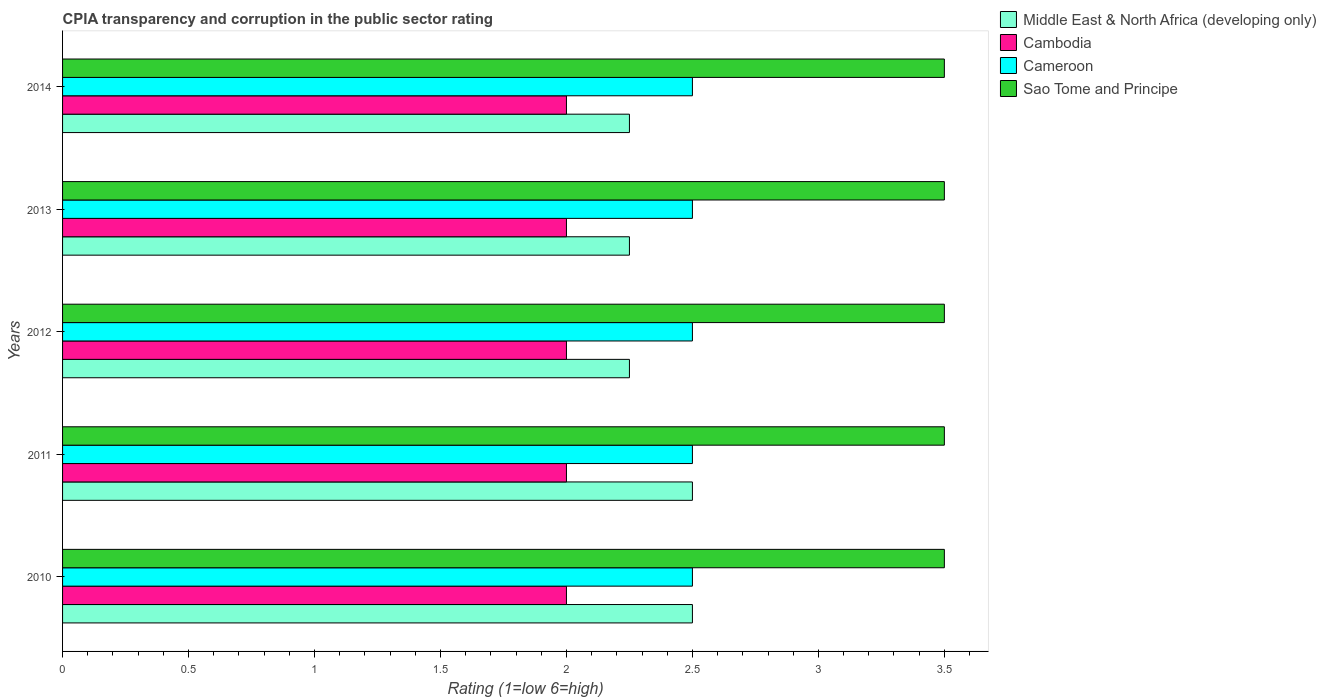How many groups of bars are there?
Provide a short and direct response. 5. How many bars are there on the 2nd tick from the bottom?
Keep it short and to the point. 4. What is the difference between the CPIA rating in Sao Tome and Principe in 2012 and that in 2013?
Offer a terse response. 0. What is the difference between the CPIA rating in Middle East & North Africa (developing only) in 2010 and the CPIA rating in Cameroon in 2013?
Offer a very short reply. 0. What is the average CPIA rating in Middle East & North Africa (developing only) per year?
Ensure brevity in your answer.  2.35. In the year 2014, what is the difference between the CPIA rating in Cambodia and CPIA rating in Middle East & North Africa (developing only)?
Offer a terse response. -0.25. In how many years, is the CPIA rating in Sao Tome and Principe greater than 1.7 ?
Offer a very short reply. 5. What is the ratio of the CPIA rating in Middle East & North Africa (developing only) in 2011 to that in 2012?
Give a very brief answer. 1.11. Is the CPIA rating in Middle East & North Africa (developing only) in 2010 less than that in 2012?
Offer a very short reply. No. Is the difference between the CPIA rating in Cambodia in 2012 and 2013 greater than the difference between the CPIA rating in Middle East & North Africa (developing only) in 2012 and 2013?
Keep it short and to the point. No. In how many years, is the CPIA rating in Cambodia greater than the average CPIA rating in Cambodia taken over all years?
Your response must be concise. 0. Is it the case that in every year, the sum of the CPIA rating in Middle East & North Africa (developing only) and CPIA rating in Cambodia is greater than the sum of CPIA rating in Sao Tome and Principe and CPIA rating in Cameroon?
Ensure brevity in your answer.  No. What does the 2nd bar from the top in 2014 represents?
Offer a very short reply. Cameroon. What does the 3rd bar from the bottom in 2014 represents?
Give a very brief answer. Cameroon. How many bars are there?
Give a very brief answer. 20. How many years are there in the graph?
Provide a short and direct response. 5. Are the values on the major ticks of X-axis written in scientific E-notation?
Offer a terse response. No. Does the graph contain any zero values?
Keep it short and to the point. No. Does the graph contain grids?
Offer a very short reply. No. How are the legend labels stacked?
Your answer should be very brief. Vertical. What is the title of the graph?
Your answer should be compact. CPIA transparency and corruption in the public sector rating. What is the Rating (1=low 6=high) in Middle East & North Africa (developing only) in 2010?
Offer a very short reply. 2.5. What is the Rating (1=low 6=high) in Cambodia in 2010?
Your answer should be compact. 2. What is the Rating (1=low 6=high) of Sao Tome and Principe in 2010?
Give a very brief answer. 3.5. What is the Rating (1=low 6=high) in Cameroon in 2011?
Offer a very short reply. 2.5. What is the Rating (1=low 6=high) in Sao Tome and Principe in 2011?
Make the answer very short. 3.5. What is the Rating (1=low 6=high) in Middle East & North Africa (developing only) in 2012?
Make the answer very short. 2.25. What is the Rating (1=low 6=high) in Cambodia in 2012?
Offer a very short reply. 2. What is the Rating (1=low 6=high) in Middle East & North Africa (developing only) in 2013?
Keep it short and to the point. 2.25. What is the Rating (1=low 6=high) of Middle East & North Africa (developing only) in 2014?
Give a very brief answer. 2.25. Across all years, what is the maximum Rating (1=low 6=high) of Cambodia?
Your answer should be compact. 2. Across all years, what is the maximum Rating (1=low 6=high) of Cameroon?
Your answer should be compact. 2.5. Across all years, what is the maximum Rating (1=low 6=high) in Sao Tome and Principe?
Provide a succinct answer. 3.5. Across all years, what is the minimum Rating (1=low 6=high) of Middle East & North Africa (developing only)?
Your answer should be compact. 2.25. Across all years, what is the minimum Rating (1=low 6=high) in Cambodia?
Make the answer very short. 2. What is the total Rating (1=low 6=high) in Middle East & North Africa (developing only) in the graph?
Provide a succinct answer. 11.75. What is the total Rating (1=low 6=high) of Cambodia in the graph?
Your answer should be very brief. 10. What is the total Rating (1=low 6=high) in Cameroon in the graph?
Your answer should be very brief. 12.5. What is the difference between the Rating (1=low 6=high) in Middle East & North Africa (developing only) in 2010 and that in 2011?
Offer a very short reply. 0. What is the difference between the Rating (1=low 6=high) of Cambodia in 2010 and that in 2011?
Offer a very short reply. 0. What is the difference between the Rating (1=low 6=high) of Cambodia in 2010 and that in 2012?
Your response must be concise. 0. What is the difference between the Rating (1=low 6=high) in Middle East & North Africa (developing only) in 2010 and that in 2014?
Offer a terse response. 0.25. What is the difference between the Rating (1=low 6=high) of Cambodia in 2010 and that in 2014?
Your answer should be very brief. 0. What is the difference between the Rating (1=low 6=high) in Cameroon in 2010 and that in 2014?
Offer a terse response. 0. What is the difference between the Rating (1=low 6=high) of Sao Tome and Principe in 2010 and that in 2014?
Your response must be concise. 0. What is the difference between the Rating (1=low 6=high) in Cambodia in 2011 and that in 2012?
Offer a terse response. 0. What is the difference between the Rating (1=low 6=high) in Sao Tome and Principe in 2011 and that in 2012?
Give a very brief answer. 0. What is the difference between the Rating (1=low 6=high) of Middle East & North Africa (developing only) in 2011 and that in 2014?
Offer a very short reply. 0.25. What is the difference between the Rating (1=low 6=high) of Cambodia in 2011 and that in 2014?
Make the answer very short. 0. What is the difference between the Rating (1=low 6=high) in Middle East & North Africa (developing only) in 2012 and that in 2013?
Offer a very short reply. 0. What is the difference between the Rating (1=low 6=high) in Cameroon in 2012 and that in 2013?
Offer a terse response. 0. What is the difference between the Rating (1=low 6=high) of Sao Tome and Principe in 2012 and that in 2013?
Your response must be concise. 0. What is the difference between the Rating (1=low 6=high) of Cameroon in 2012 and that in 2014?
Offer a terse response. 0. What is the difference between the Rating (1=low 6=high) of Sao Tome and Principe in 2012 and that in 2014?
Give a very brief answer. 0. What is the difference between the Rating (1=low 6=high) in Cambodia in 2013 and that in 2014?
Ensure brevity in your answer.  0. What is the difference between the Rating (1=low 6=high) of Middle East & North Africa (developing only) in 2010 and the Rating (1=low 6=high) of Cameroon in 2011?
Offer a very short reply. 0. What is the difference between the Rating (1=low 6=high) in Middle East & North Africa (developing only) in 2010 and the Rating (1=low 6=high) in Sao Tome and Principe in 2011?
Provide a succinct answer. -1. What is the difference between the Rating (1=low 6=high) of Middle East & North Africa (developing only) in 2010 and the Rating (1=low 6=high) of Sao Tome and Principe in 2012?
Ensure brevity in your answer.  -1. What is the difference between the Rating (1=low 6=high) of Cambodia in 2010 and the Rating (1=low 6=high) of Cameroon in 2012?
Provide a succinct answer. -0.5. What is the difference between the Rating (1=low 6=high) in Cameroon in 2010 and the Rating (1=low 6=high) in Sao Tome and Principe in 2012?
Your answer should be compact. -1. What is the difference between the Rating (1=low 6=high) of Middle East & North Africa (developing only) in 2010 and the Rating (1=low 6=high) of Cambodia in 2013?
Ensure brevity in your answer.  0.5. What is the difference between the Rating (1=low 6=high) in Middle East & North Africa (developing only) in 2010 and the Rating (1=low 6=high) in Sao Tome and Principe in 2013?
Your answer should be compact. -1. What is the difference between the Rating (1=low 6=high) of Cambodia in 2010 and the Rating (1=low 6=high) of Cameroon in 2013?
Offer a terse response. -0.5. What is the difference between the Rating (1=low 6=high) of Cambodia in 2010 and the Rating (1=low 6=high) of Sao Tome and Principe in 2013?
Your answer should be very brief. -1.5. What is the difference between the Rating (1=low 6=high) of Cameroon in 2010 and the Rating (1=low 6=high) of Sao Tome and Principe in 2013?
Ensure brevity in your answer.  -1. What is the difference between the Rating (1=low 6=high) of Middle East & North Africa (developing only) in 2010 and the Rating (1=low 6=high) of Cambodia in 2014?
Provide a short and direct response. 0.5. What is the difference between the Rating (1=low 6=high) of Cambodia in 2010 and the Rating (1=low 6=high) of Cameroon in 2014?
Make the answer very short. -0.5. What is the difference between the Rating (1=low 6=high) of Cameroon in 2010 and the Rating (1=low 6=high) of Sao Tome and Principe in 2014?
Make the answer very short. -1. What is the difference between the Rating (1=low 6=high) in Middle East & North Africa (developing only) in 2011 and the Rating (1=low 6=high) in Cameroon in 2012?
Give a very brief answer. 0. What is the difference between the Rating (1=low 6=high) of Middle East & North Africa (developing only) in 2011 and the Rating (1=low 6=high) of Sao Tome and Principe in 2012?
Your answer should be compact. -1. What is the difference between the Rating (1=low 6=high) of Cambodia in 2011 and the Rating (1=low 6=high) of Cameroon in 2012?
Keep it short and to the point. -0.5. What is the difference between the Rating (1=low 6=high) of Middle East & North Africa (developing only) in 2011 and the Rating (1=low 6=high) of Cambodia in 2013?
Make the answer very short. 0.5. What is the difference between the Rating (1=low 6=high) of Middle East & North Africa (developing only) in 2011 and the Rating (1=low 6=high) of Cameroon in 2013?
Your answer should be compact. 0. What is the difference between the Rating (1=low 6=high) of Middle East & North Africa (developing only) in 2011 and the Rating (1=low 6=high) of Sao Tome and Principe in 2013?
Your answer should be very brief. -1. What is the difference between the Rating (1=low 6=high) in Cambodia in 2011 and the Rating (1=low 6=high) in Sao Tome and Principe in 2013?
Your answer should be very brief. -1.5. What is the difference between the Rating (1=low 6=high) in Middle East & North Africa (developing only) in 2011 and the Rating (1=low 6=high) in Cameroon in 2014?
Your answer should be very brief. 0. What is the difference between the Rating (1=low 6=high) in Middle East & North Africa (developing only) in 2011 and the Rating (1=low 6=high) in Sao Tome and Principe in 2014?
Offer a very short reply. -1. What is the difference between the Rating (1=low 6=high) of Middle East & North Africa (developing only) in 2012 and the Rating (1=low 6=high) of Cameroon in 2013?
Make the answer very short. -0.25. What is the difference between the Rating (1=low 6=high) of Middle East & North Africa (developing only) in 2012 and the Rating (1=low 6=high) of Sao Tome and Principe in 2013?
Provide a short and direct response. -1.25. What is the difference between the Rating (1=low 6=high) in Cambodia in 2012 and the Rating (1=low 6=high) in Sao Tome and Principe in 2013?
Offer a terse response. -1.5. What is the difference between the Rating (1=low 6=high) in Cameroon in 2012 and the Rating (1=low 6=high) in Sao Tome and Principe in 2013?
Make the answer very short. -1. What is the difference between the Rating (1=low 6=high) of Middle East & North Africa (developing only) in 2012 and the Rating (1=low 6=high) of Sao Tome and Principe in 2014?
Your response must be concise. -1.25. What is the difference between the Rating (1=low 6=high) of Cameroon in 2012 and the Rating (1=low 6=high) of Sao Tome and Principe in 2014?
Provide a succinct answer. -1. What is the difference between the Rating (1=low 6=high) in Middle East & North Africa (developing only) in 2013 and the Rating (1=low 6=high) in Cambodia in 2014?
Provide a short and direct response. 0.25. What is the difference between the Rating (1=low 6=high) of Middle East & North Africa (developing only) in 2013 and the Rating (1=low 6=high) of Cameroon in 2014?
Provide a short and direct response. -0.25. What is the difference between the Rating (1=low 6=high) in Middle East & North Africa (developing only) in 2013 and the Rating (1=low 6=high) in Sao Tome and Principe in 2014?
Provide a succinct answer. -1.25. What is the difference between the Rating (1=low 6=high) of Cambodia in 2013 and the Rating (1=low 6=high) of Cameroon in 2014?
Your answer should be compact. -0.5. What is the average Rating (1=low 6=high) in Middle East & North Africa (developing only) per year?
Provide a succinct answer. 2.35. What is the average Rating (1=low 6=high) of Cameroon per year?
Make the answer very short. 2.5. In the year 2010, what is the difference between the Rating (1=low 6=high) in Middle East & North Africa (developing only) and Rating (1=low 6=high) in Cambodia?
Your response must be concise. 0.5. In the year 2010, what is the difference between the Rating (1=low 6=high) of Middle East & North Africa (developing only) and Rating (1=low 6=high) of Cameroon?
Offer a very short reply. 0. In the year 2010, what is the difference between the Rating (1=low 6=high) of Cambodia and Rating (1=low 6=high) of Sao Tome and Principe?
Offer a very short reply. -1.5. In the year 2010, what is the difference between the Rating (1=low 6=high) in Cameroon and Rating (1=low 6=high) in Sao Tome and Principe?
Your answer should be very brief. -1. In the year 2011, what is the difference between the Rating (1=low 6=high) in Middle East & North Africa (developing only) and Rating (1=low 6=high) in Sao Tome and Principe?
Provide a succinct answer. -1. In the year 2011, what is the difference between the Rating (1=low 6=high) in Cameroon and Rating (1=low 6=high) in Sao Tome and Principe?
Provide a short and direct response. -1. In the year 2012, what is the difference between the Rating (1=low 6=high) in Middle East & North Africa (developing only) and Rating (1=low 6=high) in Cambodia?
Give a very brief answer. 0.25. In the year 2012, what is the difference between the Rating (1=low 6=high) in Middle East & North Africa (developing only) and Rating (1=low 6=high) in Cameroon?
Offer a terse response. -0.25. In the year 2012, what is the difference between the Rating (1=low 6=high) of Middle East & North Africa (developing only) and Rating (1=low 6=high) of Sao Tome and Principe?
Make the answer very short. -1.25. In the year 2012, what is the difference between the Rating (1=low 6=high) in Cambodia and Rating (1=low 6=high) in Cameroon?
Ensure brevity in your answer.  -0.5. In the year 2012, what is the difference between the Rating (1=low 6=high) in Cambodia and Rating (1=low 6=high) in Sao Tome and Principe?
Your response must be concise. -1.5. In the year 2013, what is the difference between the Rating (1=low 6=high) in Middle East & North Africa (developing only) and Rating (1=low 6=high) in Sao Tome and Principe?
Make the answer very short. -1.25. In the year 2013, what is the difference between the Rating (1=low 6=high) of Cambodia and Rating (1=low 6=high) of Cameroon?
Provide a succinct answer. -0.5. In the year 2013, what is the difference between the Rating (1=low 6=high) in Cambodia and Rating (1=low 6=high) in Sao Tome and Principe?
Your answer should be very brief. -1.5. In the year 2013, what is the difference between the Rating (1=low 6=high) in Cameroon and Rating (1=low 6=high) in Sao Tome and Principe?
Offer a very short reply. -1. In the year 2014, what is the difference between the Rating (1=low 6=high) of Middle East & North Africa (developing only) and Rating (1=low 6=high) of Cameroon?
Your answer should be compact. -0.25. In the year 2014, what is the difference between the Rating (1=low 6=high) in Middle East & North Africa (developing only) and Rating (1=low 6=high) in Sao Tome and Principe?
Make the answer very short. -1.25. In the year 2014, what is the difference between the Rating (1=low 6=high) in Cambodia and Rating (1=low 6=high) in Cameroon?
Make the answer very short. -0.5. What is the ratio of the Rating (1=low 6=high) of Cameroon in 2010 to that in 2011?
Offer a terse response. 1. What is the ratio of the Rating (1=low 6=high) in Cameroon in 2010 to that in 2013?
Your answer should be very brief. 1. What is the ratio of the Rating (1=low 6=high) of Sao Tome and Principe in 2010 to that in 2013?
Provide a short and direct response. 1. What is the ratio of the Rating (1=low 6=high) in Cameroon in 2010 to that in 2014?
Offer a very short reply. 1. What is the ratio of the Rating (1=low 6=high) of Cambodia in 2011 to that in 2012?
Your answer should be very brief. 1. What is the ratio of the Rating (1=low 6=high) in Cameroon in 2011 to that in 2012?
Provide a succinct answer. 1. What is the ratio of the Rating (1=low 6=high) in Middle East & North Africa (developing only) in 2011 to that in 2013?
Offer a very short reply. 1.11. What is the ratio of the Rating (1=low 6=high) in Cambodia in 2011 to that in 2013?
Provide a short and direct response. 1. What is the ratio of the Rating (1=low 6=high) in Cameroon in 2011 to that in 2013?
Give a very brief answer. 1. What is the ratio of the Rating (1=low 6=high) of Cameroon in 2011 to that in 2014?
Offer a terse response. 1. What is the ratio of the Rating (1=low 6=high) of Middle East & North Africa (developing only) in 2012 to that in 2013?
Make the answer very short. 1. What is the ratio of the Rating (1=low 6=high) of Cambodia in 2012 to that in 2013?
Give a very brief answer. 1. What is the ratio of the Rating (1=low 6=high) of Sao Tome and Principe in 2012 to that in 2013?
Provide a short and direct response. 1. What is the ratio of the Rating (1=low 6=high) of Middle East & North Africa (developing only) in 2012 to that in 2014?
Make the answer very short. 1. What is the difference between the highest and the second highest Rating (1=low 6=high) in Cambodia?
Provide a succinct answer. 0. What is the difference between the highest and the lowest Rating (1=low 6=high) of Middle East & North Africa (developing only)?
Provide a succinct answer. 0.25. What is the difference between the highest and the lowest Rating (1=low 6=high) of Cambodia?
Offer a very short reply. 0. What is the difference between the highest and the lowest Rating (1=low 6=high) of Cameroon?
Your answer should be compact. 0. What is the difference between the highest and the lowest Rating (1=low 6=high) of Sao Tome and Principe?
Your response must be concise. 0. 